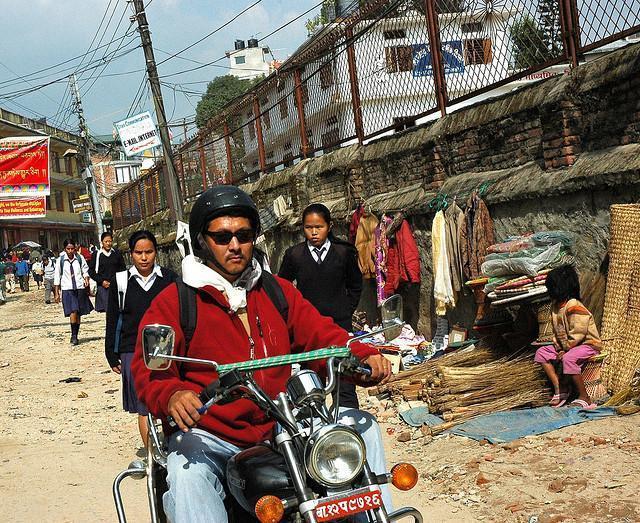How many people are visible?
Give a very brief answer. 5. 